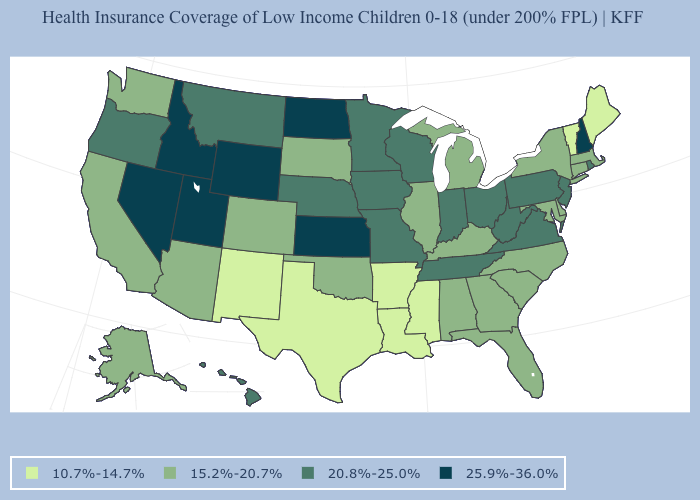Does North Dakota have the highest value in the USA?
Write a very short answer. Yes. Among the states that border New York , does Vermont have the lowest value?
Short answer required. Yes. Is the legend a continuous bar?
Answer briefly. No. What is the highest value in states that border Wyoming?
Give a very brief answer. 25.9%-36.0%. Does Missouri have a lower value than California?
Be succinct. No. What is the lowest value in the USA?
Give a very brief answer. 10.7%-14.7%. Name the states that have a value in the range 20.8%-25.0%?
Give a very brief answer. Hawaii, Indiana, Iowa, Minnesota, Missouri, Montana, Nebraska, New Jersey, Ohio, Oregon, Pennsylvania, Rhode Island, Tennessee, Virginia, West Virginia, Wisconsin. What is the value of California?
Keep it brief. 15.2%-20.7%. Among the states that border Minnesota , which have the highest value?
Concise answer only. North Dakota. What is the value of Arkansas?
Keep it brief. 10.7%-14.7%. Among the states that border California , does Arizona have the lowest value?
Concise answer only. Yes. What is the value of Georgia?
Keep it brief. 15.2%-20.7%. Among the states that border Ohio , does Kentucky have the lowest value?
Give a very brief answer. Yes. What is the highest value in the USA?
Concise answer only. 25.9%-36.0%. 